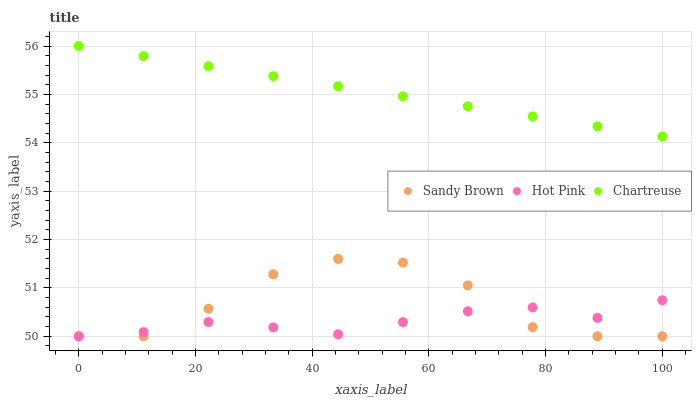Does Hot Pink have the minimum area under the curve?
Answer yes or no. Yes. Does Chartreuse have the maximum area under the curve?
Answer yes or no. Yes. Does Sandy Brown have the minimum area under the curve?
Answer yes or no. No. Does Sandy Brown have the maximum area under the curve?
Answer yes or no. No. Is Chartreuse the smoothest?
Answer yes or no. Yes. Is Sandy Brown the roughest?
Answer yes or no. Yes. Is Hot Pink the smoothest?
Answer yes or no. No. Is Hot Pink the roughest?
Answer yes or no. No. Does Hot Pink have the lowest value?
Answer yes or no. Yes. Does Chartreuse have the highest value?
Answer yes or no. Yes. Does Sandy Brown have the highest value?
Answer yes or no. No. Is Sandy Brown less than Chartreuse?
Answer yes or no. Yes. Is Chartreuse greater than Hot Pink?
Answer yes or no. Yes. Does Hot Pink intersect Sandy Brown?
Answer yes or no. Yes. Is Hot Pink less than Sandy Brown?
Answer yes or no. No. Is Hot Pink greater than Sandy Brown?
Answer yes or no. No. Does Sandy Brown intersect Chartreuse?
Answer yes or no. No. 